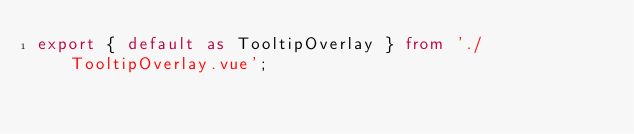<code> <loc_0><loc_0><loc_500><loc_500><_TypeScript_>export { default as TooltipOverlay } from './TooltipOverlay.vue';
</code> 